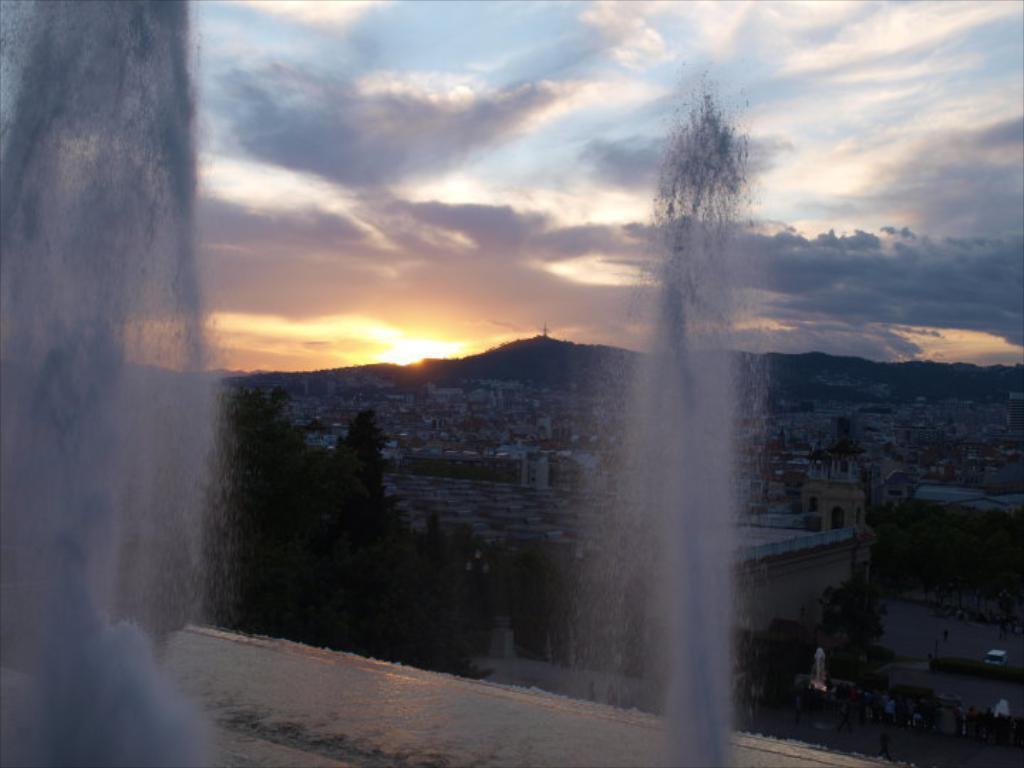Could you give a brief overview of what you see in this image? In this picture, it seems like fountains in the foreground area and there are houses, trees, people, sky and a sun in the background area. 